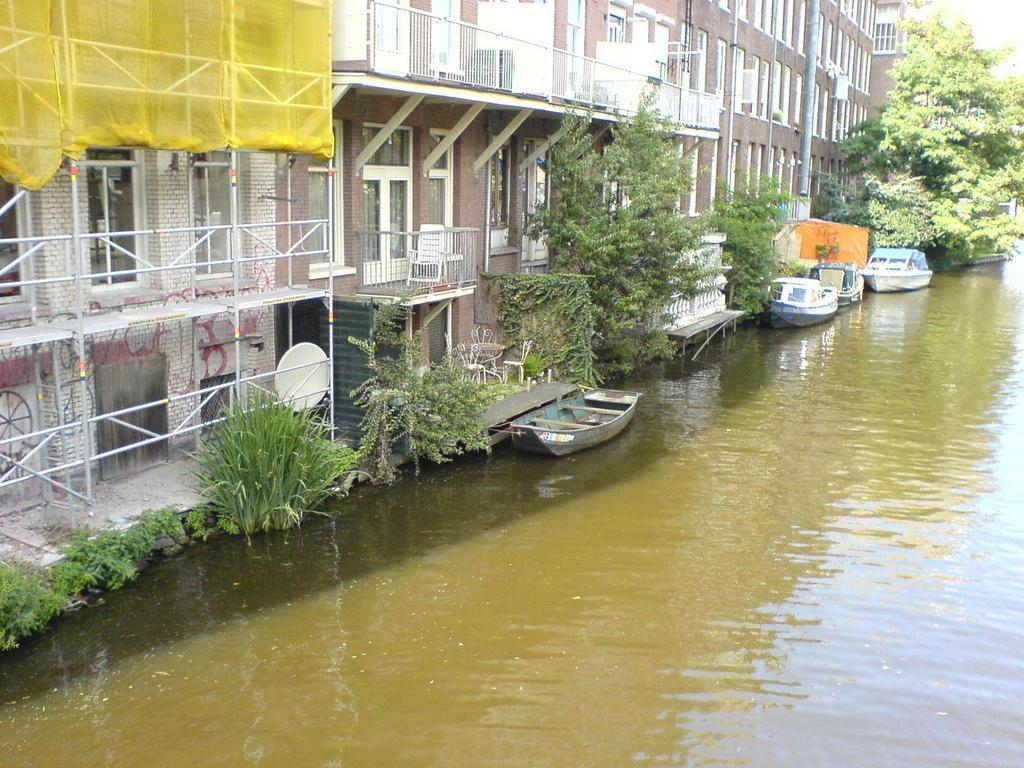What type of structures can be seen in the image? There are buildings in the image. What is located on the right side of the image? There are trees on the right side of the image. What natural element is visible in the image? There is water visible in the image. What is floating on the water in the image? There are boats on the water. What type of cloth is draped over the buildings in the image? There is no cloth draped over the buildings in the image. How far away is the distance between the trees and the water in the image? The provided facts do not give information about the distance between the trees and the water, so it cannot be determined from the image. 